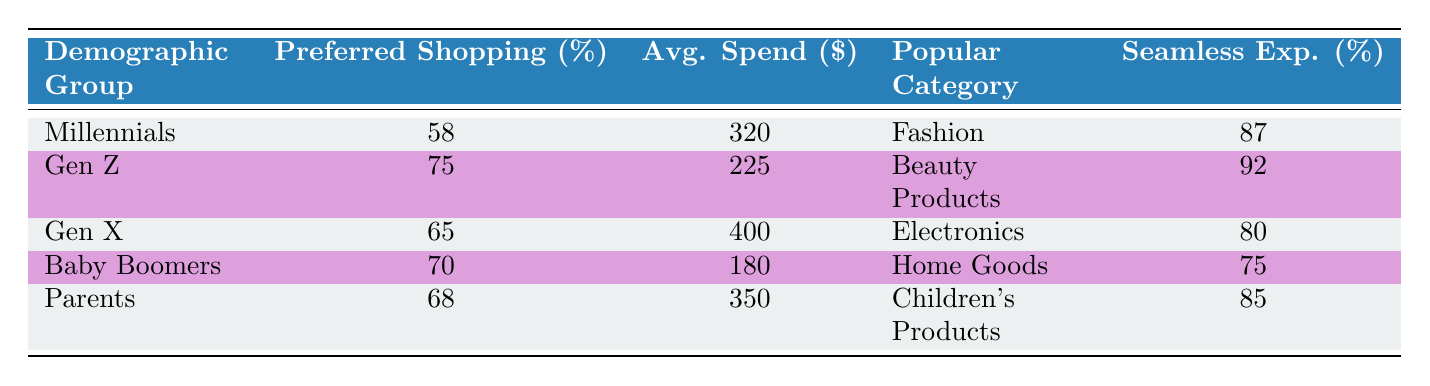What demographic group has the highest percentage preferring mobile shopping? From the table, Millennials prefer mobile shopping at 58%. This value is higher compared to Baby Boomers (70% preferring email promotions), Gen Z (75% preferring social media shopping), Gen X (65% preferring desktop shopping), and Parents (68% preferring value-based shopping). Therefore, Millennials are the group with the highest percentage preferring mobile shopping.
Answer: Millennials What is the average spending per month for Baby Boomers? The table shows that Baby Boomers have an average spend of 180 dollars per month. This is a specific data point stated directly in the table.
Answer: 180 Which demographic group spends the most on average? The table states the Average Spend Per Month for Gen X is 400 dollars, which is the highest among all demographic groups listed. Other groups have lower average spends, making Gen X the highest spending group.
Answer: Gen X How many demographic groups prefer a seamless shopping experience at 85% or greater? The table indicates that Millennials (87%), Gen Z (92%), and Parents (85%) have a seamless experience percentage that is 85% or greater. Counting these three groups gives us the answer.
Answer: 3 Is it true that Gen Z prefers social media shopping? The table clearly shows that 75% of Gen Z prefer social media shopping, confirming the statement is true.
Answer: Yes What is the difference in average spending per month between Gen X and Baby Boomers? The average spending for Gen X is 400 dollars, while for Baby Boomers it is 180 dollars. Therefore, the difference is calculated as 400 - 180 = 220 dollars.
Answer: 220 Which demographic has the lowest importance placed on a seamless experience? Reviewing the table, Baby Boomers have the lowest percentage (75%) for the importance of a seamless experience compared to all other groups, which is indicated as a specific data point.
Answer: Baby Boomers What percentage of Parents prefer value-based shopping? The table shows that 68% of Parents prefer value-based shopping. This is taken directly from the data provided.
Answer: 68 Which demographic group has the most popular purchase category of Electronics, and what percentage prefer desktop shopping? The table indicates that Gen X has Electronics as the most popular purchase category, and it shows 65% preferring desktop shopping. Therefore, both values are captured in the same demographic group, Gen X.
Answer: Gen X, 65% 